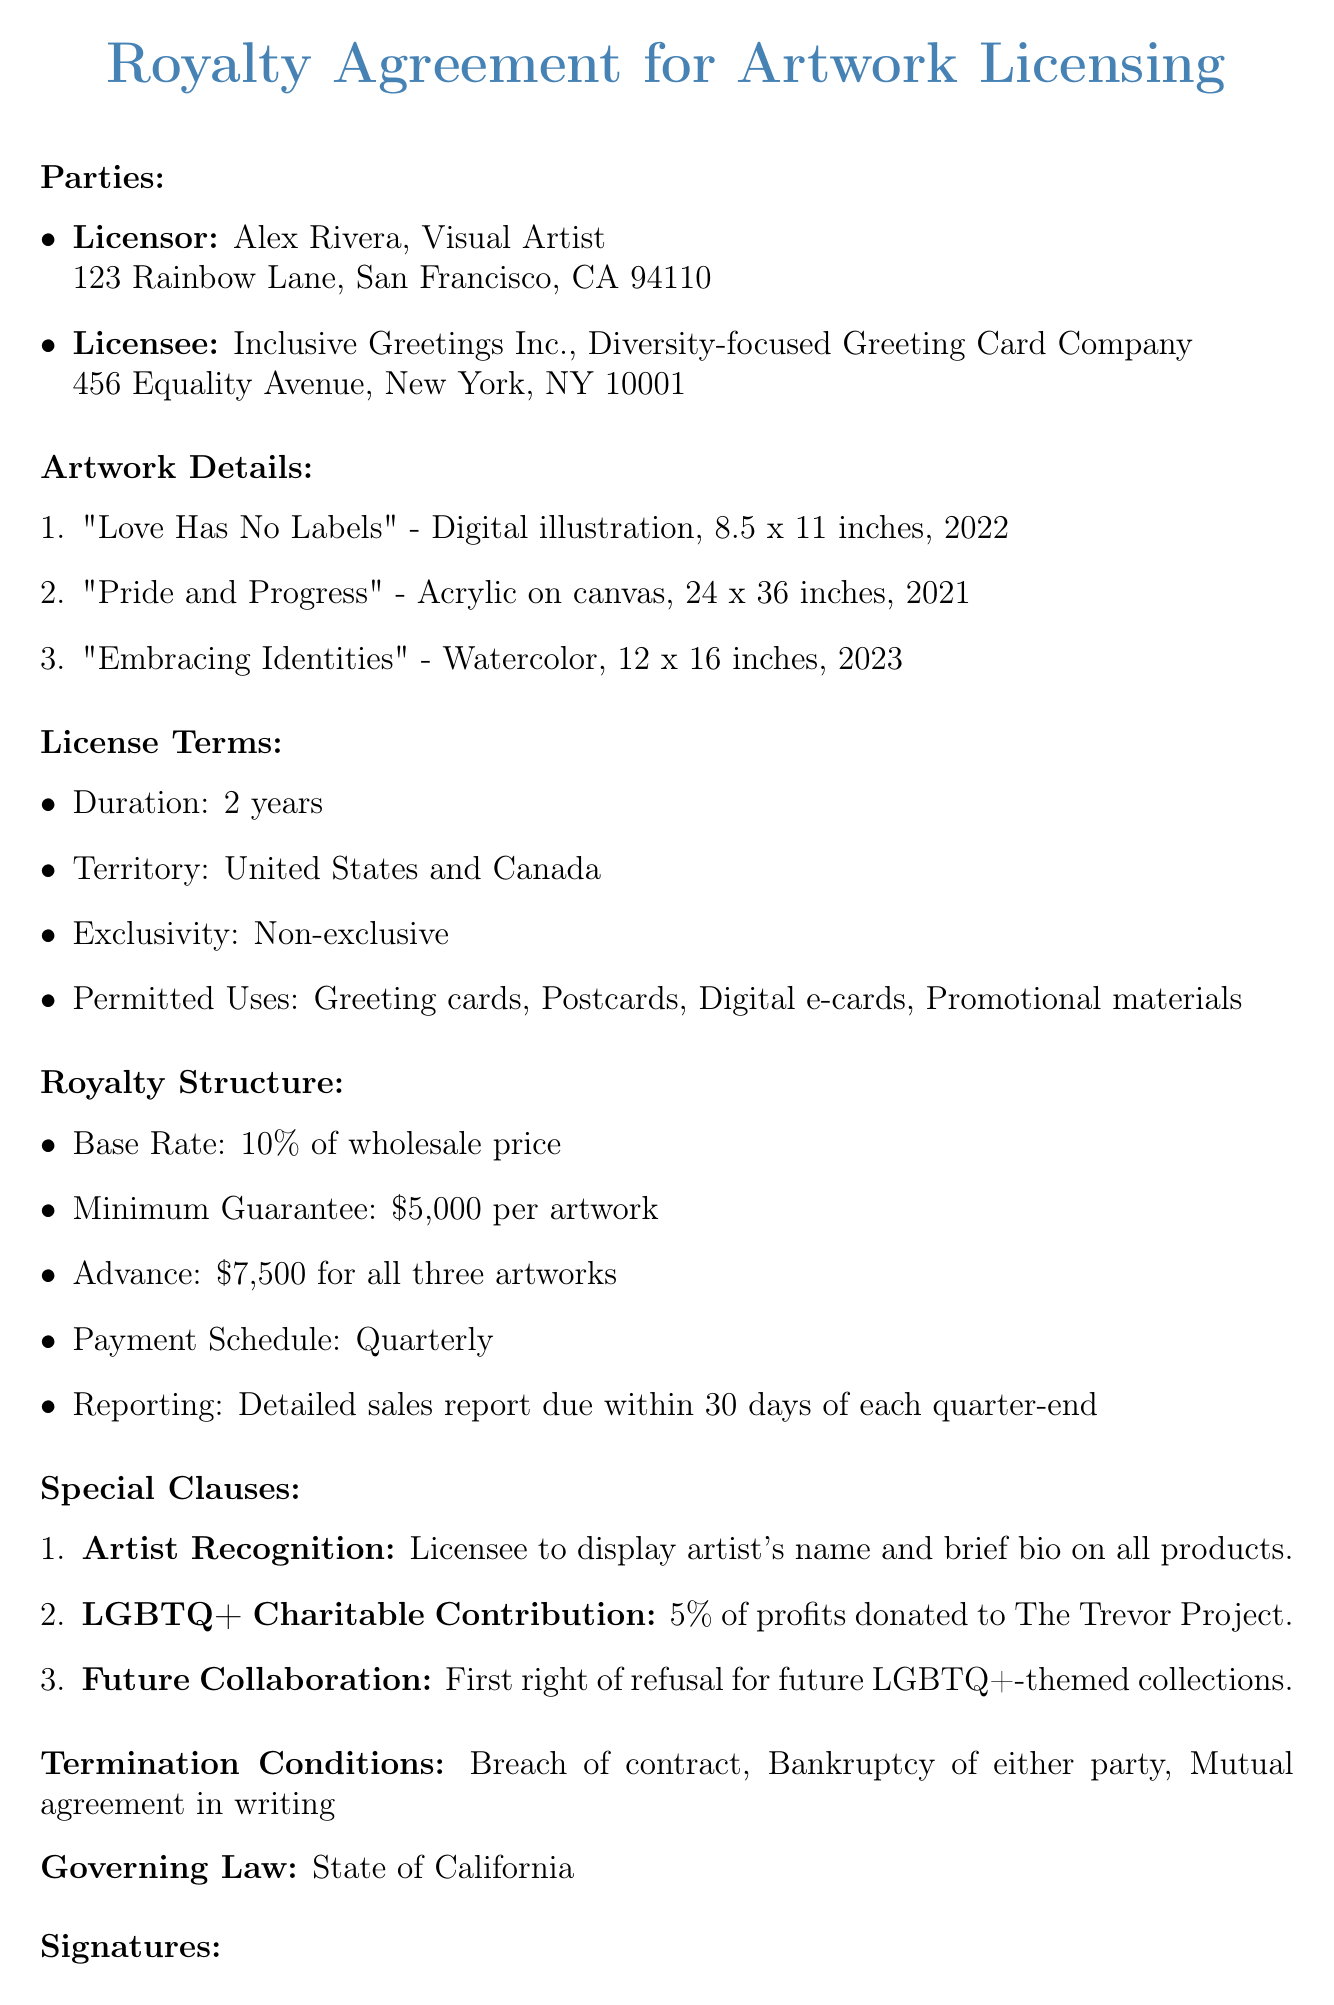what is the title of the agreement? The title of the agreement is the first line of the document.
Answer: Royalty Agreement for Artwork Licensing who is the licensor? The licensor's name is listed under the parties section of the document.
Answer: Alex Rivera what is the duration of the license? The duration is specified in the license terms section.
Answer: 2 years how many artworks are included in the advance payment? The advance payment statement mentions the number of artworks.
Answer: three artworks what percentage of profits will be donated to The Trevor Project? This information is found in the special clauses about charitable contributions.
Answer: 5% what is the minimum guarantee per artwork? The minimum guarantee is mentioned in the royalty structure.
Answer: $5,000 per artwork who is the licensee? The name of the licensee is found in the parties section of the document.
Answer: Inclusive Greetings Inc what type of exclusivity is mentioned in the license terms? The exclusivity type is specified in the license terms section.
Answer: Non-exclusive what is the payment schedule for the royalties? The payment schedule is detailed in the royalty structure section.
Answer: Quarterly 